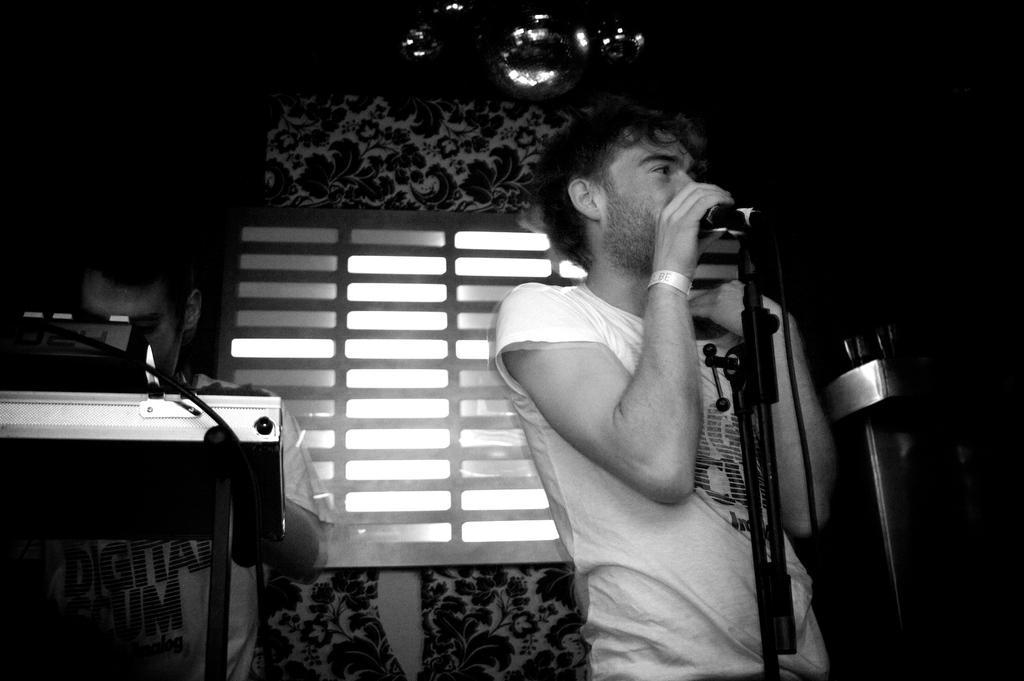In one or two sentences, can you explain what this image depicts? A man is standing and singing with a mic in front of him. There is another man beside him standing. 